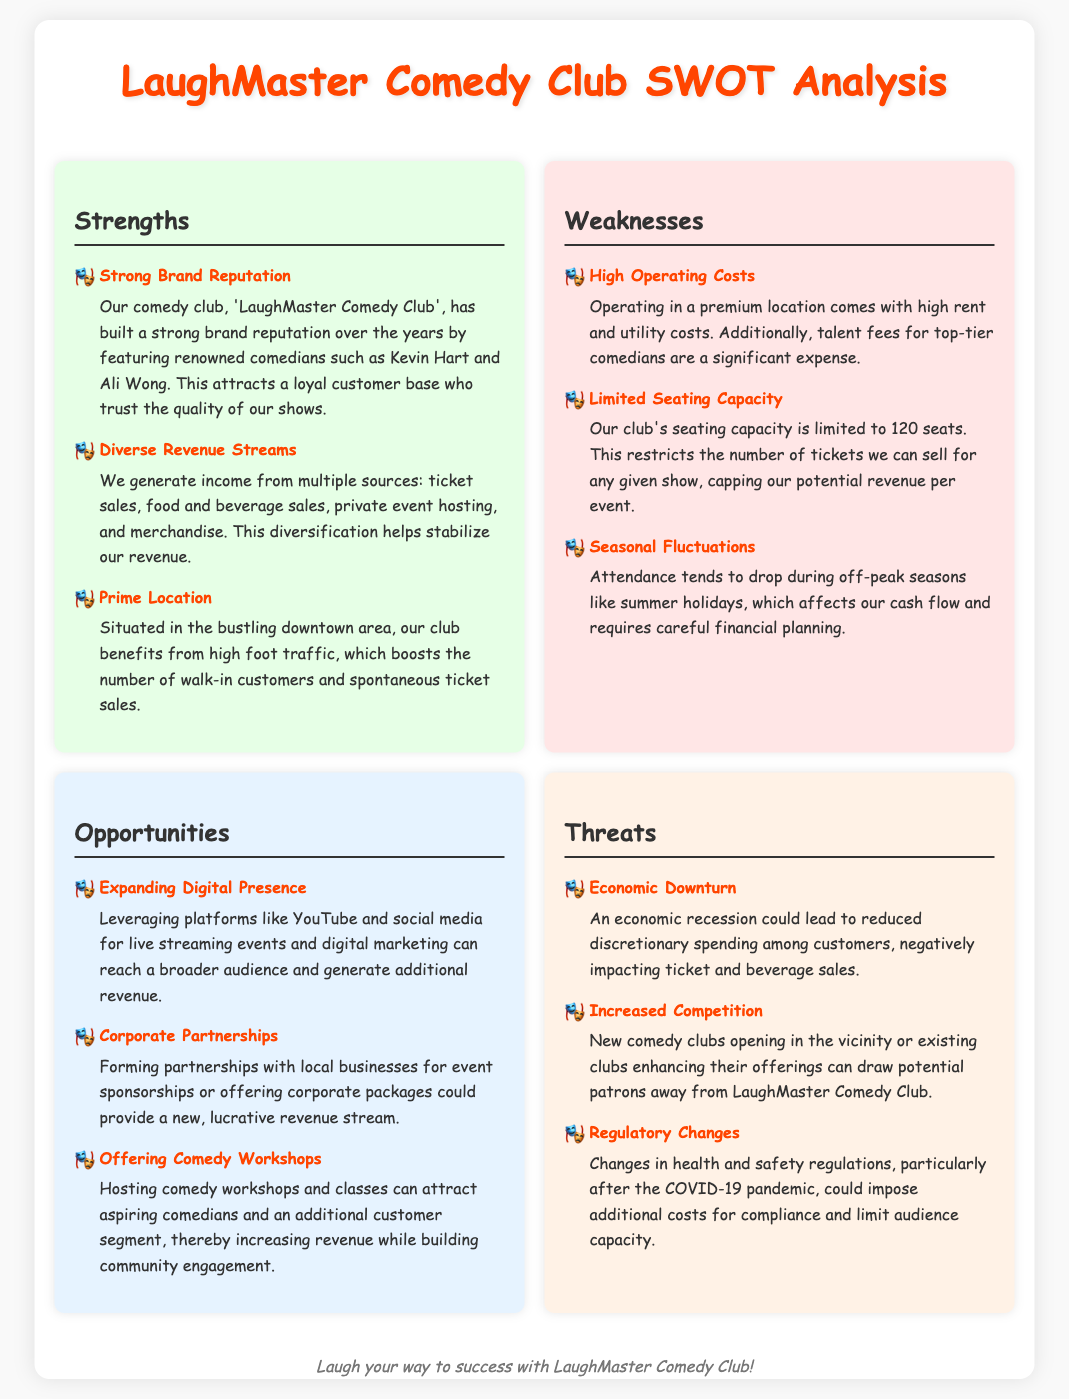What is the name of the comedy club? The document explicitly names the comedy club as "LaughMaster Comedy Club."
Answer: LaughMaster Comedy Club Who are two renowned comedians mentioned? The document lists "Kevin Hart" and "Ali Wong" as renowned comedians featured at the club.
Answer: Kevin Hart, Ali Wong What is one weakness related to venue size? The document mentions the "Limited Seating Capacity" as a weakness, capping ticket sales.
Answer: Limited Seating Capacity What opportunity involves digital marketing? The document discusses "Expanding Digital Presence" as an opportunity to reach a broader audience.
Answer: Expanding Digital Presence What is a potential threat to customer spending? The document notes "Economic Downturn" as a threat that could reduce discretionary spending.
Answer: Economic Downturn What revenue source is related to events outside regular shows? "Private event hosting" is mentioned as a revenue source in the Strengths section.
Answer: Private event hosting What aspect of operating costs is highlighted? The document specifies "High Operating Costs" due to location and talent fees as a weakness.
Answer: High Operating Costs What type of event could be a new revenue stream? The document mentions "Comedy Workshops" as an opportunity to attract new customers and increase revenue.
Answer: Comedy Workshops 